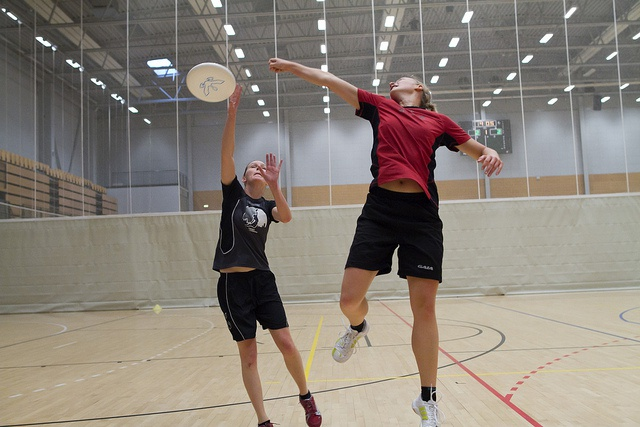Describe the objects in this image and their specific colors. I can see people in black, brown, maroon, and darkgray tones, people in black, brown, darkgray, and gray tones, and frisbee in black, tan, and gray tones in this image. 